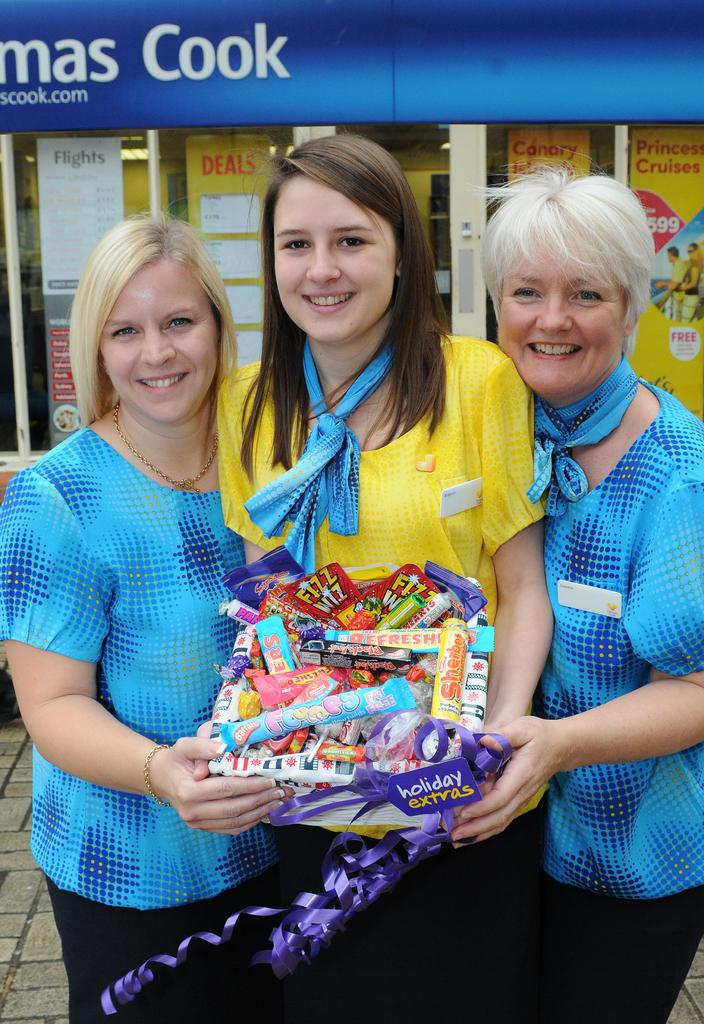How many people are in the image? There are 3 people in the image. What are the people doing in the image? The people are standing and holding chocolates. Can you describe the clothing of the person at the center? The person at the center is wearing a yellow t-shirt. What color t-shirts are the other two people wearing? The other two people are wearing blue t-shirts. What can be seen in the background of the image? There is a building in the background of the image. What type of loaf is being sliced on the cushion in the image? There is no loaf or cushion present in the image; it features 3 people holding chocolates with a building in the background. 